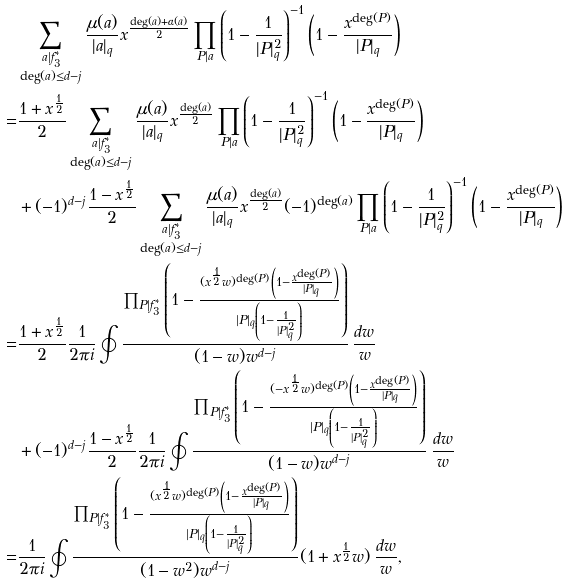Convert formula to latex. <formula><loc_0><loc_0><loc_500><loc_500>& \sum _ { \substack { a | f _ { 3 } ^ { * } \\ \deg ( a ) \leq d - j } } \frac { \mu ( a ) } { | a | _ { q } } x ^ { \frac { \deg ( a ) + \alpha ( a ) } { 2 } } \prod _ { P | a } \left ( 1 - \frac { 1 } { | P | _ { q } ^ { 2 } } \right ) ^ { - 1 } \left ( 1 - \frac { x ^ { \deg ( P ) } } { | P | _ { q } } \right ) \\ = & \frac { 1 + x ^ { \frac { 1 } { 2 } } } { 2 } \sum _ { \substack { a | f _ { 3 } ^ { * } \\ \deg ( a ) \leq d - j } } \frac { \mu ( a ) } { | a | _ { q } } x ^ { \frac { \deg ( a ) } { 2 } } \prod _ { P | a } \left ( 1 - \frac { 1 } { | P | _ { q } ^ { 2 } } \right ) ^ { - 1 } \left ( 1 - \frac { x ^ { \deg ( P ) } } { | P | _ { q } } \right ) \\ & + ( - 1 ) ^ { d - j } \frac { 1 - x ^ { \frac { 1 } { 2 } } } { 2 } \sum _ { \substack { a | f _ { 3 } ^ { * } \\ \deg ( a ) \leq d - j } } \frac { \mu ( a ) } { | a | _ { q } } x ^ { \frac { \deg ( a ) } { 2 } } ( - 1 ) ^ { \deg ( a ) } \prod _ { P | a } \left ( 1 - \frac { 1 } { | P | _ { q } ^ { 2 } } \right ) ^ { - 1 } \left ( 1 - \frac { x ^ { \deg ( P ) } } { | P | _ { q } } \right ) \\ = & \frac { 1 + x ^ { \frac { 1 } { 2 } } } { 2 } \frac { 1 } { 2 \pi i } \oint \frac { \prod _ { P | f _ { 3 } ^ { * } } \left ( 1 - \frac { ( x ^ { \frac { 1 } { 2 } } w ) ^ { \deg ( P ) } \left ( 1 - \frac { x ^ { \deg ( P ) } } { | P | _ { q } } \right ) } { | P | _ { q } \left ( 1 - \frac { 1 } { | P | _ { q } ^ { 2 } } \right ) } \right ) } { ( 1 - w ) w ^ { d - j } } \, \frac { d w } { w } \\ & + ( - 1 ) ^ { d - j } \frac { 1 - x ^ { \frac { 1 } { 2 } } } { 2 } \frac { 1 } { 2 \pi i } \oint \frac { \prod _ { P | f _ { 3 } ^ { * } } \left ( 1 - \frac { ( - x ^ { \frac { 1 } { 2 } } w ) ^ { \deg ( P ) } \left ( 1 - \frac { x ^ { \deg ( P ) } } { | P | _ { q } } \right ) } { | P | _ { q } \left ( 1 - \frac { 1 } { | P | _ { q } ^ { 2 } } \right ) } \right ) } { ( 1 - w ) w ^ { d - j } } \, \frac { d w } { w } \\ = & \frac { 1 } { 2 \pi i } \oint \frac { \prod _ { P | f _ { 3 } ^ { * } } \left ( 1 - \frac { ( x ^ { \frac { 1 } { 2 } } w ) ^ { \deg ( P ) } \left ( 1 - \frac { x ^ { \deg ( P ) } } { | P | _ { q } } \right ) } { | P | _ { q } \left ( 1 - \frac { 1 } { | P | _ { q } ^ { 2 } } \right ) } \right ) } { ( 1 - w ^ { 2 } ) w ^ { d - j } } ( 1 + x ^ { \frac { 1 } { 2 } } w ) \, \frac { d w } { w } ,</formula> 